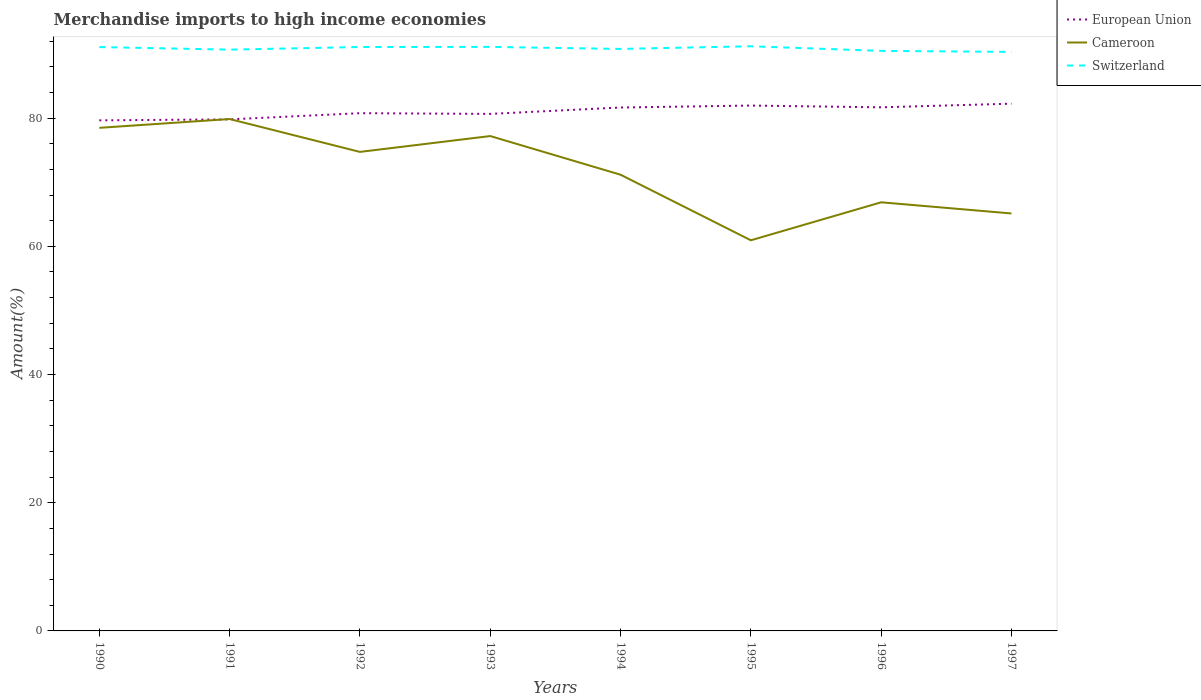How many different coloured lines are there?
Give a very brief answer. 3. Across all years, what is the maximum percentage of amount earned from merchandise imports in Cameroon?
Make the answer very short. 60.94. In which year was the percentage of amount earned from merchandise imports in European Union maximum?
Make the answer very short. 1990. What is the total percentage of amount earned from merchandise imports in Cameroon in the graph?
Provide a succinct answer. 6.05. What is the difference between the highest and the second highest percentage of amount earned from merchandise imports in Switzerland?
Offer a very short reply. 0.88. What is the difference between the highest and the lowest percentage of amount earned from merchandise imports in Cameroon?
Make the answer very short. 4. Is the percentage of amount earned from merchandise imports in Switzerland strictly greater than the percentage of amount earned from merchandise imports in European Union over the years?
Your answer should be very brief. No. How many years are there in the graph?
Keep it short and to the point. 8. What is the difference between two consecutive major ticks on the Y-axis?
Make the answer very short. 20. Where does the legend appear in the graph?
Provide a succinct answer. Top right. What is the title of the graph?
Your response must be concise. Merchandise imports to high income economies. What is the label or title of the Y-axis?
Ensure brevity in your answer.  Amount(%). What is the Amount(%) in European Union in 1990?
Offer a very short reply. 79.65. What is the Amount(%) in Cameroon in 1990?
Provide a short and direct response. 78.49. What is the Amount(%) in Switzerland in 1990?
Give a very brief answer. 91.09. What is the Amount(%) in European Union in 1991?
Your answer should be very brief. 79.8. What is the Amount(%) of Cameroon in 1991?
Make the answer very short. 79.86. What is the Amount(%) in Switzerland in 1991?
Keep it short and to the point. 90.68. What is the Amount(%) of European Union in 1992?
Provide a short and direct response. 80.77. What is the Amount(%) of Cameroon in 1992?
Your answer should be very brief. 74.73. What is the Amount(%) in Switzerland in 1992?
Keep it short and to the point. 91.09. What is the Amount(%) of European Union in 1993?
Give a very brief answer. 80.66. What is the Amount(%) in Cameroon in 1993?
Ensure brevity in your answer.  77.2. What is the Amount(%) in Switzerland in 1993?
Keep it short and to the point. 91.11. What is the Amount(%) of European Union in 1994?
Give a very brief answer. 81.65. What is the Amount(%) of Cameroon in 1994?
Make the answer very short. 71.17. What is the Amount(%) in Switzerland in 1994?
Your answer should be very brief. 90.79. What is the Amount(%) of European Union in 1995?
Offer a terse response. 81.96. What is the Amount(%) of Cameroon in 1995?
Keep it short and to the point. 60.94. What is the Amount(%) of Switzerland in 1995?
Provide a succinct answer. 91.21. What is the Amount(%) in European Union in 1996?
Provide a succinct answer. 81.69. What is the Amount(%) in Cameroon in 1996?
Provide a short and direct response. 66.87. What is the Amount(%) of Switzerland in 1996?
Offer a very short reply. 90.49. What is the Amount(%) in European Union in 1997?
Give a very brief answer. 82.26. What is the Amount(%) of Cameroon in 1997?
Your answer should be very brief. 65.13. What is the Amount(%) in Switzerland in 1997?
Offer a terse response. 90.33. Across all years, what is the maximum Amount(%) in European Union?
Provide a short and direct response. 82.26. Across all years, what is the maximum Amount(%) of Cameroon?
Keep it short and to the point. 79.86. Across all years, what is the maximum Amount(%) of Switzerland?
Give a very brief answer. 91.21. Across all years, what is the minimum Amount(%) in European Union?
Give a very brief answer. 79.65. Across all years, what is the minimum Amount(%) of Cameroon?
Your answer should be compact. 60.94. Across all years, what is the minimum Amount(%) of Switzerland?
Give a very brief answer. 90.33. What is the total Amount(%) in European Union in the graph?
Your answer should be very brief. 648.43. What is the total Amount(%) of Cameroon in the graph?
Your answer should be very brief. 574.38. What is the total Amount(%) of Switzerland in the graph?
Give a very brief answer. 726.79. What is the difference between the Amount(%) of European Union in 1990 and that in 1991?
Your answer should be compact. -0.15. What is the difference between the Amount(%) of Cameroon in 1990 and that in 1991?
Keep it short and to the point. -1.37. What is the difference between the Amount(%) in Switzerland in 1990 and that in 1991?
Offer a very short reply. 0.4. What is the difference between the Amount(%) of European Union in 1990 and that in 1992?
Ensure brevity in your answer.  -1.12. What is the difference between the Amount(%) in Cameroon in 1990 and that in 1992?
Keep it short and to the point. 3.76. What is the difference between the Amount(%) of Switzerland in 1990 and that in 1992?
Offer a terse response. -0.01. What is the difference between the Amount(%) in European Union in 1990 and that in 1993?
Your answer should be very brief. -1. What is the difference between the Amount(%) in Cameroon in 1990 and that in 1993?
Provide a succinct answer. 1.28. What is the difference between the Amount(%) in Switzerland in 1990 and that in 1993?
Your response must be concise. -0.03. What is the difference between the Amount(%) of European Union in 1990 and that in 1994?
Make the answer very short. -2. What is the difference between the Amount(%) of Cameroon in 1990 and that in 1994?
Make the answer very short. 7.31. What is the difference between the Amount(%) in Switzerland in 1990 and that in 1994?
Keep it short and to the point. 0.29. What is the difference between the Amount(%) in European Union in 1990 and that in 1995?
Provide a succinct answer. -2.3. What is the difference between the Amount(%) of Cameroon in 1990 and that in 1995?
Offer a terse response. 17.54. What is the difference between the Amount(%) of Switzerland in 1990 and that in 1995?
Ensure brevity in your answer.  -0.12. What is the difference between the Amount(%) of European Union in 1990 and that in 1996?
Your answer should be compact. -2.03. What is the difference between the Amount(%) in Cameroon in 1990 and that in 1996?
Keep it short and to the point. 11.62. What is the difference between the Amount(%) of Switzerland in 1990 and that in 1996?
Your answer should be very brief. 0.6. What is the difference between the Amount(%) in European Union in 1990 and that in 1997?
Provide a short and direct response. -2.6. What is the difference between the Amount(%) of Cameroon in 1990 and that in 1997?
Your answer should be compact. 13.36. What is the difference between the Amount(%) of Switzerland in 1990 and that in 1997?
Keep it short and to the point. 0.76. What is the difference between the Amount(%) in European Union in 1991 and that in 1992?
Offer a terse response. -0.97. What is the difference between the Amount(%) of Cameroon in 1991 and that in 1992?
Keep it short and to the point. 5.13. What is the difference between the Amount(%) in Switzerland in 1991 and that in 1992?
Keep it short and to the point. -0.41. What is the difference between the Amount(%) in European Union in 1991 and that in 1993?
Keep it short and to the point. -0.86. What is the difference between the Amount(%) in Cameroon in 1991 and that in 1993?
Your answer should be compact. 2.65. What is the difference between the Amount(%) of Switzerland in 1991 and that in 1993?
Provide a succinct answer. -0.43. What is the difference between the Amount(%) of European Union in 1991 and that in 1994?
Your answer should be compact. -1.85. What is the difference between the Amount(%) of Cameroon in 1991 and that in 1994?
Ensure brevity in your answer.  8.69. What is the difference between the Amount(%) in Switzerland in 1991 and that in 1994?
Provide a short and direct response. -0.11. What is the difference between the Amount(%) in European Union in 1991 and that in 1995?
Provide a succinct answer. -2.15. What is the difference between the Amount(%) in Cameroon in 1991 and that in 1995?
Give a very brief answer. 18.92. What is the difference between the Amount(%) of Switzerland in 1991 and that in 1995?
Offer a terse response. -0.52. What is the difference between the Amount(%) in European Union in 1991 and that in 1996?
Your response must be concise. -1.88. What is the difference between the Amount(%) of Cameroon in 1991 and that in 1996?
Provide a succinct answer. 12.99. What is the difference between the Amount(%) in Switzerland in 1991 and that in 1996?
Your response must be concise. 0.2. What is the difference between the Amount(%) of European Union in 1991 and that in 1997?
Your response must be concise. -2.45. What is the difference between the Amount(%) of Cameroon in 1991 and that in 1997?
Ensure brevity in your answer.  14.73. What is the difference between the Amount(%) in Switzerland in 1991 and that in 1997?
Keep it short and to the point. 0.35. What is the difference between the Amount(%) of European Union in 1992 and that in 1993?
Provide a short and direct response. 0.11. What is the difference between the Amount(%) of Cameroon in 1992 and that in 1993?
Your answer should be compact. -2.47. What is the difference between the Amount(%) of Switzerland in 1992 and that in 1993?
Provide a short and direct response. -0.02. What is the difference between the Amount(%) in European Union in 1992 and that in 1994?
Keep it short and to the point. -0.89. What is the difference between the Amount(%) of Cameroon in 1992 and that in 1994?
Offer a terse response. 3.56. What is the difference between the Amount(%) of Switzerland in 1992 and that in 1994?
Make the answer very short. 0.3. What is the difference between the Amount(%) of European Union in 1992 and that in 1995?
Offer a terse response. -1.19. What is the difference between the Amount(%) in Cameroon in 1992 and that in 1995?
Offer a terse response. 13.79. What is the difference between the Amount(%) of Switzerland in 1992 and that in 1995?
Give a very brief answer. -0.12. What is the difference between the Amount(%) of European Union in 1992 and that in 1996?
Offer a terse response. -0.92. What is the difference between the Amount(%) in Cameroon in 1992 and that in 1996?
Provide a succinct answer. 7.86. What is the difference between the Amount(%) in Switzerland in 1992 and that in 1996?
Your response must be concise. 0.61. What is the difference between the Amount(%) of European Union in 1992 and that in 1997?
Make the answer very short. -1.49. What is the difference between the Amount(%) of Cameroon in 1992 and that in 1997?
Make the answer very short. 9.6. What is the difference between the Amount(%) in Switzerland in 1992 and that in 1997?
Your answer should be compact. 0.76. What is the difference between the Amount(%) of European Union in 1993 and that in 1994?
Your response must be concise. -1. What is the difference between the Amount(%) of Cameroon in 1993 and that in 1994?
Ensure brevity in your answer.  6.03. What is the difference between the Amount(%) of Switzerland in 1993 and that in 1994?
Keep it short and to the point. 0.32. What is the difference between the Amount(%) in European Union in 1993 and that in 1995?
Make the answer very short. -1.3. What is the difference between the Amount(%) in Cameroon in 1993 and that in 1995?
Keep it short and to the point. 16.26. What is the difference between the Amount(%) in Switzerland in 1993 and that in 1995?
Your answer should be very brief. -0.1. What is the difference between the Amount(%) of European Union in 1993 and that in 1996?
Keep it short and to the point. -1.03. What is the difference between the Amount(%) of Cameroon in 1993 and that in 1996?
Your answer should be very brief. 10.34. What is the difference between the Amount(%) of Switzerland in 1993 and that in 1996?
Your response must be concise. 0.62. What is the difference between the Amount(%) of European Union in 1993 and that in 1997?
Provide a short and direct response. -1.6. What is the difference between the Amount(%) of Cameroon in 1993 and that in 1997?
Ensure brevity in your answer.  12.08. What is the difference between the Amount(%) in Switzerland in 1993 and that in 1997?
Your answer should be very brief. 0.78. What is the difference between the Amount(%) of European Union in 1994 and that in 1995?
Keep it short and to the point. -0.3. What is the difference between the Amount(%) in Cameroon in 1994 and that in 1995?
Keep it short and to the point. 10.23. What is the difference between the Amount(%) of Switzerland in 1994 and that in 1995?
Your response must be concise. -0.41. What is the difference between the Amount(%) in European Union in 1994 and that in 1996?
Keep it short and to the point. -0.03. What is the difference between the Amount(%) of Cameroon in 1994 and that in 1996?
Ensure brevity in your answer.  4.3. What is the difference between the Amount(%) of Switzerland in 1994 and that in 1996?
Your answer should be very brief. 0.31. What is the difference between the Amount(%) of European Union in 1994 and that in 1997?
Make the answer very short. -0.6. What is the difference between the Amount(%) in Cameroon in 1994 and that in 1997?
Make the answer very short. 6.05. What is the difference between the Amount(%) in Switzerland in 1994 and that in 1997?
Your response must be concise. 0.47. What is the difference between the Amount(%) of European Union in 1995 and that in 1996?
Offer a very short reply. 0.27. What is the difference between the Amount(%) in Cameroon in 1995 and that in 1996?
Give a very brief answer. -5.93. What is the difference between the Amount(%) in Switzerland in 1995 and that in 1996?
Provide a succinct answer. 0.72. What is the difference between the Amount(%) of European Union in 1995 and that in 1997?
Your answer should be compact. -0.3. What is the difference between the Amount(%) in Cameroon in 1995 and that in 1997?
Your response must be concise. -4.18. What is the difference between the Amount(%) of Switzerland in 1995 and that in 1997?
Provide a short and direct response. 0.88. What is the difference between the Amount(%) in European Union in 1996 and that in 1997?
Your answer should be compact. -0.57. What is the difference between the Amount(%) in Cameroon in 1996 and that in 1997?
Your response must be concise. 1.74. What is the difference between the Amount(%) of Switzerland in 1996 and that in 1997?
Your answer should be compact. 0.16. What is the difference between the Amount(%) in European Union in 1990 and the Amount(%) in Cameroon in 1991?
Offer a terse response. -0.2. What is the difference between the Amount(%) of European Union in 1990 and the Amount(%) of Switzerland in 1991?
Give a very brief answer. -11.03. What is the difference between the Amount(%) of Cameroon in 1990 and the Amount(%) of Switzerland in 1991?
Provide a short and direct response. -12.2. What is the difference between the Amount(%) of European Union in 1990 and the Amount(%) of Cameroon in 1992?
Provide a succinct answer. 4.92. What is the difference between the Amount(%) in European Union in 1990 and the Amount(%) in Switzerland in 1992?
Give a very brief answer. -11.44. What is the difference between the Amount(%) in Cameroon in 1990 and the Amount(%) in Switzerland in 1992?
Offer a very short reply. -12.61. What is the difference between the Amount(%) of European Union in 1990 and the Amount(%) of Cameroon in 1993?
Make the answer very short. 2.45. What is the difference between the Amount(%) of European Union in 1990 and the Amount(%) of Switzerland in 1993?
Offer a very short reply. -11.46. What is the difference between the Amount(%) in Cameroon in 1990 and the Amount(%) in Switzerland in 1993?
Give a very brief answer. -12.63. What is the difference between the Amount(%) of European Union in 1990 and the Amount(%) of Cameroon in 1994?
Your response must be concise. 8.48. What is the difference between the Amount(%) of European Union in 1990 and the Amount(%) of Switzerland in 1994?
Your answer should be very brief. -11.14. What is the difference between the Amount(%) in Cameroon in 1990 and the Amount(%) in Switzerland in 1994?
Your response must be concise. -12.31. What is the difference between the Amount(%) of European Union in 1990 and the Amount(%) of Cameroon in 1995?
Give a very brief answer. 18.71. What is the difference between the Amount(%) in European Union in 1990 and the Amount(%) in Switzerland in 1995?
Provide a short and direct response. -11.55. What is the difference between the Amount(%) in Cameroon in 1990 and the Amount(%) in Switzerland in 1995?
Provide a short and direct response. -12.72. What is the difference between the Amount(%) of European Union in 1990 and the Amount(%) of Cameroon in 1996?
Ensure brevity in your answer.  12.79. What is the difference between the Amount(%) of European Union in 1990 and the Amount(%) of Switzerland in 1996?
Your answer should be compact. -10.83. What is the difference between the Amount(%) of Cameroon in 1990 and the Amount(%) of Switzerland in 1996?
Offer a terse response. -12. What is the difference between the Amount(%) in European Union in 1990 and the Amount(%) in Cameroon in 1997?
Provide a short and direct response. 14.53. What is the difference between the Amount(%) in European Union in 1990 and the Amount(%) in Switzerland in 1997?
Your answer should be compact. -10.67. What is the difference between the Amount(%) of Cameroon in 1990 and the Amount(%) of Switzerland in 1997?
Offer a terse response. -11.84. What is the difference between the Amount(%) in European Union in 1991 and the Amount(%) in Cameroon in 1992?
Provide a short and direct response. 5.07. What is the difference between the Amount(%) in European Union in 1991 and the Amount(%) in Switzerland in 1992?
Provide a short and direct response. -11.29. What is the difference between the Amount(%) of Cameroon in 1991 and the Amount(%) of Switzerland in 1992?
Keep it short and to the point. -11.23. What is the difference between the Amount(%) in European Union in 1991 and the Amount(%) in Cameroon in 1993?
Your response must be concise. 2.6. What is the difference between the Amount(%) of European Union in 1991 and the Amount(%) of Switzerland in 1993?
Keep it short and to the point. -11.31. What is the difference between the Amount(%) of Cameroon in 1991 and the Amount(%) of Switzerland in 1993?
Give a very brief answer. -11.25. What is the difference between the Amount(%) of European Union in 1991 and the Amount(%) of Cameroon in 1994?
Your response must be concise. 8.63. What is the difference between the Amount(%) of European Union in 1991 and the Amount(%) of Switzerland in 1994?
Your answer should be very brief. -10.99. What is the difference between the Amount(%) in Cameroon in 1991 and the Amount(%) in Switzerland in 1994?
Provide a short and direct response. -10.94. What is the difference between the Amount(%) in European Union in 1991 and the Amount(%) in Cameroon in 1995?
Your response must be concise. 18.86. What is the difference between the Amount(%) in European Union in 1991 and the Amount(%) in Switzerland in 1995?
Your answer should be very brief. -11.41. What is the difference between the Amount(%) in Cameroon in 1991 and the Amount(%) in Switzerland in 1995?
Give a very brief answer. -11.35. What is the difference between the Amount(%) of European Union in 1991 and the Amount(%) of Cameroon in 1996?
Offer a terse response. 12.94. What is the difference between the Amount(%) of European Union in 1991 and the Amount(%) of Switzerland in 1996?
Your response must be concise. -10.68. What is the difference between the Amount(%) of Cameroon in 1991 and the Amount(%) of Switzerland in 1996?
Give a very brief answer. -10.63. What is the difference between the Amount(%) of European Union in 1991 and the Amount(%) of Cameroon in 1997?
Provide a short and direct response. 14.68. What is the difference between the Amount(%) in European Union in 1991 and the Amount(%) in Switzerland in 1997?
Provide a short and direct response. -10.53. What is the difference between the Amount(%) in Cameroon in 1991 and the Amount(%) in Switzerland in 1997?
Your answer should be very brief. -10.47. What is the difference between the Amount(%) in European Union in 1992 and the Amount(%) in Cameroon in 1993?
Ensure brevity in your answer.  3.57. What is the difference between the Amount(%) in European Union in 1992 and the Amount(%) in Switzerland in 1993?
Make the answer very short. -10.34. What is the difference between the Amount(%) in Cameroon in 1992 and the Amount(%) in Switzerland in 1993?
Make the answer very short. -16.38. What is the difference between the Amount(%) of European Union in 1992 and the Amount(%) of Cameroon in 1994?
Keep it short and to the point. 9.6. What is the difference between the Amount(%) of European Union in 1992 and the Amount(%) of Switzerland in 1994?
Provide a succinct answer. -10.03. What is the difference between the Amount(%) in Cameroon in 1992 and the Amount(%) in Switzerland in 1994?
Offer a very short reply. -16.07. What is the difference between the Amount(%) of European Union in 1992 and the Amount(%) of Cameroon in 1995?
Keep it short and to the point. 19.83. What is the difference between the Amount(%) in European Union in 1992 and the Amount(%) in Switzerland in 1995?
Offer a very short reply. -10.44. What is the difference between the Amount(%) of Cameroon in 1992 and the Amount(%) of Switzerland in 1995?
Provide a short and direct response. -16.48. What is the difference between the Amount(%) of European Union in 1992 and the Amount(%) of Cameroon in 1996?
Keep it short and to the point. 13.9. What is the difference between the Amount(%) in European Union in 1992 and the Amount(%) in Switzerland in 1996?
Provide a succinct answer. -9.72. What is the difference between the Amount(%) of Cameroon in 1992 and the Amount(%) of Switzerland in 1996?
Provide a short and direct response. -15.76. What is the difference between the Amount(%) of European Union in 1992 and the Amount(%) of Cameroon in 1997?
Offer a very short reply. 15.64. What is the difference between the Amount(%) in European Union in 1992 and the Amount(%) in Switzerland in 1997?
Provide a short and direct response. -9.56. What is the difference between the Amount(%) of Cameroon in 1992 and the Amount(%) of Switzerland in 1997?
Your answer should be very brief. -15.6. What is the difference between the Amount(%) in European Union in 1993 and the Amount(%) in Cameroon in 1994?
Make the answer very short. 9.49. What is the difference between the Amount(%) of European Union in 1993 and the Amount(%) of Switzerland in 1994?
Ensure brevity in your answer.  -10.14. What is the difference between the Amount(%) in Cameroon in 1993 and the Amount(%) in Switzerland in 1994?
Provide a short and direct response. -13.59. What is the difference between the Amount(%) of European Union in 1993 and the Amount(%) of Cameroon in 1995?
Offer a very short reply. 19.72. What is the difference between the Amount(%) of European Union in 1993 and the Amount(%) of Switzerland in 1995?
Give a very brief answer. -10.55. What is the difference between the Amount(%) of Cameroon in 1993 and the Amount(%) of Switzerland in 1995?
Your answer should be compact. -14.01. What is the difference between the Amount(%) in European Union in 1993 and the Amount(%) in Cameroon in 1996?
Your response must be concise. 13.79. What is the difference between the Amount(%) in European Union in 1993 and the Amount(%) in Switzerland in 1996?
Provide a short and direct response. -9.83. What is the difference between the Amount(%) in Cameroon in 1993 and the Amount(%) in Switzerland in 1996?
Keep it short and to the point. -13.28. What is the difference between the Amount(%) of European Union in 1993 and the Amount(%) of Cameroon in 1997?
Your answer should be compact. 15.53. What is the difference between the Amount(%) of European Union in 1993 and the Amount(%) of Switzerland in 1997?
Offer a very short reply. -9.67. What is the difference between the Amount(%) in Cameroon in 1993 and the Amount(%) in Switzerland in 1997?
Ensure brevity in your answer.  -13.13. What is the difference between the Amount(%) in European Union in 1994 and the Amount(%) in Cameroon in 1995?
Keep it short and to the point. 20.71. What is the difference between the Amount(%) in European Union in 1994 and the Amount(%) in Switzerland in 1995?
Give a very brief answer. -9.55. What is the difference between the Amount(%) in Cameroon in 1994 and the Amount(%) in Switzerland in 1995?
Your response must be concise. -20.04. What is the difference between the Amount(%) in European Union in 1994 and the Amount(%) in Cameroon in 1996?
Provide a short and direct response. 14.79. What is the difference between the Amount(%) in European Union in 1994 and the Amount(%) in Switzerland in 1996?
Provide a short and direct response. -8.83. What is the difference between the Amount(%) in Cameroon in 1994 and the Amount(%) in Switzerland in 1996?
Your answer should be compact. -19.32. What is the difference between the Amount(%) in European Union in 1994 and the Amount(%) in Cameroon in 1997?
Your answer should be compact. 16.53. What is the difference between the Amount(%) of European Union in 1994 and the Amount(%) of Switzerland in 1997?
Keep it short and to the point. -8.67. What is the difference between the Amount(%) of Cameroon in 1994 and the Amount(%) of Switzerland in 1997?
Your answer should be compact. -19.16. What is the difference between the Amount(%) in European Union in 1995 and the Amount(%) in Cameroon in 1996?
Make the answer very short. 15.09. What is the difference between the Amount(%) of European Union in 1995 and the Amount(%) of Switzerland in 1996?
Give a very brief answer. -8.53. What is the difference between the Amount(%) in Cameroon in 1995 and the Amount(%) in Switzerland in 1996?
Your response must be concise. -29.55. What is the difference between the Amount(%) in European Union in 1995 and the Amount(%) in Cameroon in 1997?
Make the answer very short. 16.83. What is the difference between the Amount(%) of European Union in 1995 and the Amount(%) of Switzerland in 1997?
Keep it short and to the point. -8.37. What is the difference between the Amount(%) of Cameroon in 1995 and the Amount(%) of Switzerland in 1997?
Give a very brief answer. -29.39. What is the difference between the Amount(%) of European Union in 1996 and the Amount(%) of Cameroon in 1997?
Your answer should be very brief. 16.56. What is the difference between the Amount(%) of European Union in 1996 and the Amount(%) of Switzerland in 1997?
Provide a short and direct response. -8.64. What is the difference between the Amount(%) of Cameroon in 1996 and the Amount(%) of Switzerland in 1997?
Provide a short and direct response. -23.46. What is the average Amount(%) in European Union per year?
Ensure brevity in your answer.  81.05. What is the average Amount(%) of Cameroon per year?
Offer a terse response. 71.8. What is the average Amount(%) of Switzerland per year?
Give a very brief answer. 90.85. In the year 1990, what is the difference between the Amount(%) in European Union and Amount(%) in Cameroon?
Your answer should be compact. 1.17. In the year 1990, what is the difference between the Amount(%) of European Union and Amount(%) of Switzerland?
Your answer should be compact. -11.43. In the year 1990, what is the difference between the Amount(%) of Cameroon and Amount(%) of Switzerland?
Make the answer very short. -12.6. In the year 1991, what is the difference between the Amount(%) in European Union and Amount(%) in Cameroon?
Keep it short and to the point. -0.05. In the year 1991, what is the difference between the Amount(%) in European Union and Amount(%) in Switzerland?
Keep it short and to the point. -10.88. In the year 1991, what is the difference between the Amount(%) in Cameroon and Amount(%) in Switzerland?
Your response must be concise. -10.83. In the year 1992, what is the difference between the Amount(%) of European Union and Amount(%) of Cameroon?
Give a very brief answer. 6.04. In the year 1992, what is the difference between the Amount(%) of European Union and Amount(%) of Switzerland?
Provide a short and direct response. -10.32. In the year 1992, what is the difference between the Amount(%) in Cameroon and Amount(%) in Switzerland?
Your answer should be very brief. -16.36. In the year 1993, what is the difference between the Amount(%) of European Union and Amount(%) of Cameroon?
Your answer should be compact. 3.46. In the year 1993, what is the difference between the Amount(%) in European Union and Amount(%) in Switzerland?
Keep it short and to the point. -10.45. In the year 1993, what is the difference between the Amount(%) of Cameroon and Amount(%) of Switzerland?
Your answer should be very brief. -13.91. In the year 1994, what is the difference between the Amount(%) of European Union and Amount(%) of Cameroon?
Ensure brevity in your answer.  10.48. In the year 1994, what is the difference between the Amount(%) of European Union and Amount(%) of Switzerland?
Your answer should be very brief. -9.14. In the year 1994, what is the difference between the Amount(%) in Cameroon and Amount(%) in Switzerland?
Provide a succinct answer. -19.62. In the year 1995, what is the difference between the Amount(%) in European Union and Amount(%) in Cameroon?
Make the answer very short. 21.02. In the year 1995, what is the difference between the Amount(%) of European Union and Amount(%) of Switzerland?
Offer a terse response. -9.25. In the year 1995, what is the difference between the Amount(%) in Cameroon and Amount(%) in Switzerland?
Make the answer very short. -30.27. In the year 1996, what is the difference between the Amount(%) in European Union and Amount(%) in Cameroon?
Provide a short and direct response. 14.82. In the year 1996, what is the difference between the Amount(%) of European Union and Amount(%) of Switzerland?
Keep it short and to the point. -8.8. In the year 1996, what is the difference between the Amount(%) of Cameroon and Amount(%) of Switzerland?
Your response must be concise. -23.62. In the year 1997, what is the difference between the Amount(%) in European Union and Amount(%) in Cameroon?
Keep it short and to the point. 17.13. In the year 1997, what is the difference between the Amount(%) in European Union and Amount(%) in Switzerland?
Your response must be concise. -8.07. In the year 1997, what is the difference between the Amount(%) in Cameroon and Amount(%) in Switzerland?
Your answer should be compact. -25.2. What is the ratio of the Amount(%) of European Union in 1990 to that in 1991?
Your answer should be compact. 1. What is the ratio of the Amount(%) of Cameroon in 1990 to that in 1991?
Your response must be concise. 0.98. What is the ratio of the Amount(%) of Switzerland in 1990 to that in 1991?
Offer a terse response. 1. What is the ratio of the Amount(%) in European Union in 1990 to that in 1992?
Provide a short and direct response. 0.99. What is the ratio of the Amount(%) in Cameroon in 1990 to that in 1992?
Give a very brief answer. 1.05. What is the ratio of the Amount(%) of Switzerland in 1990 to that in 1992?
Make the answer very short. 1. What is the ratio of the Amount(%) in European Union in 1990 to that in 1993?
Provide a succinct answer. 0.99. What is the ratio of the Amount(%) in Cameroon in 1990 to that in 1993?
Keep it short and to the point. 1.02. What is the ratio of the Amount(%) in European Union in 1990 to that in 1994?
Keep it short and to the point. 0.98. What is the ratio of the Amount(%) in Cameroon in 1990 to that in 1994?
Make the answer very short. 1.1. What is the ratio of the Amount(%) of Switzerland in 1990 to that in 1994?
Offer a terse response. 1. What is the ratio of the Amount(%) in European Union in 1990 to that in 1995?
Your answer should be very brief. 0.97. What is the ratio of the Amount(%) in Cameroon in 1990 to that in 1995?
Your answer should be compact. 1.29. What is the ratio of the Amount(%) in European Union in 1990 to that in 1996?
Offer a very short reply. 0.98. What is the ratio of the Amount(%) in Cameroon in 1990 to that in 1996?
Your answer should be compact. 1.17. What is the ratio of the Amount(%) in Switzerland in 1990 to that in 1996?
Offer a very short reply. 1.01. What is the ratio of the Amount(%) of European Union in 1990 to that in 1997?
Give a very brief answer. 0.97. What is the ratio of the Amount(%) in Cameroon in 1990 to that in 1997?
Offer a terse response. 1.21. What is the ratio of the Amount(%) of Switzerland in 1990 to that in 1997?
Ensure brevity in your answer.  1.01. What is the ratio of the Amount(%) in Cameroon in 1991 to that in 1992?
Provide a succinct answer. 1.07. What is the ratio of the Amount(%) of European Union in 1991 to that in 1993?
Offer a very short reply. 0.99. What is the ratio of the Amount(%) of Cameroon in 1991 to that in 1993?
Provide a succinct answer. 1.03. What is the ratio of the Amount(%) in Switzerland in 1991 to that in 1993?
Give a very brief answer. 1. What is the ratio of the Amount(%) in European Union in 1991 to that in 1994?
Your answer should be very brief. 0.98. What is the ratio of the Amount(%) of Cameroon in 1991 to that in 1994?
Offer a terse response. 1.12. What is the ratio of the Amount(%) in European Union in 1991 to that in 1995?
Provide a succinct answer. 0.97. What is the ratio of the Amount(%) of Cameroon in 1991 to that in 1995?
Ensure brevity in your answer.  1.31. What is the ratio of the Amount(%) in Cameroon in 1991 to that in 1996?
Keep it short and to the point. 1.19. What is the ratio of the Amount(%) in Switzerland in 1991 to that in 1996?
Keep it short and to the point. 1. What is the ratio of the Amount(%) in European Union in 1991 to that in 1997?
Your response must be concise. 0.97. What is the ratio of the Amount(%) in Cameroon in 1991 to that in 1997?
Give a very brief answer. 1.23. What is the ratio of the Amount(%) of European Union in 1992 to that in 1993?
Offer a terse response. 1. What is the ratio of the Amount(%) of European Union in 1992 to that in 1994?
Give a very brief answer. 0.99. What is the ratio of the Amount(%) in Switzerland in 1992 to that in 1994?
Make the answer very short. 1. What is the ratio of the Amount(%) of European Union in 1992 to that in 1995?
Provide a succinct answer. 0.99. What is the ratio of the Amount(%) in Cameroon in 1992 to that in 1995?
Keep it short and to the point. 1.23. What is the ratio of the Amount(%) in European Union in 1992 to that in 1996?
Your answer should be compact. 0.99. What is the ratio of the Amount(%) of Cameroon in 1992 to that in 1996?
Keep it short and to the point. 1.12. What is the ratio of the Amount(%) in Switzerland in 1992 to that in 1996?
Your response must be concise. 1.01. What is the ratio of the Amount(%) in European Union in 1992 to that in 1997?
Provide a short and direct response. 0.98. What is the ratio of the Amount(%) of Cameroon in 1992 to that in 1997?
Make the answer very short. 1.15. What is the ratio of the Amount(%) of Switzerland in 1992 to that in 1997?
Offer a terse response. 1.01. What is the ratio of the Amount(%) of Cameroon in 1993 to that in 1994?
Provide a short and direct response. 1.08. What is the ratio of the Amount(%) of Switzerland in 1993 to that in 1994?
Keep it short and to the point. 1. What is the ratio of the Amount(%) in European Union in 1993 to that in 1995?
Your answer should be very brief. 0.98. What is the ratio of the Amount(%) in Cameroon in 1993 to that in 1995?
Your response must be concise. 1.27. What is the ratio of the Amount(%) in European Union in 1993 to that in 1996?
Your answer should be very brief. 0.99. What is the ratio of the Amount(%) in Cameroon in 1993 to that in 1996?
Offer a terse response. 1.15. What is the ratio of the Amount(%) of European Union in 1993 to that in 1997?
Your response must be concise. 0.98. What is the ratio of the Amount(%) in Cameroon in 1993 to that in 1997?
Give a very brief answer. 1.19. What is the ratio of the Amount(%) of Switzerland in 1993 to that in 1997?
Give a very brief answer. 1.01. What is the ratio of the Amount(%) of European Union in 1994 to that in 1995?
Provide a short and direct response. 1. What is the ratio of the Amount(%) of Cameroon in 1994 to that in 1995?
Offer a very short reply. 1.17. What is the ratio of the Amount(%) in Switzerland in 1994 to that in 1995?
Offer a terse response. 1. What is the ratio of the Amount(%) of European Union in 1994 to that in 1996?
Provide a short and direct response. 1. What is the ratio of the Amount(%) of Cameroon in 1994 to that in 1996?
Make the answer very short. 1.06. What is the ratio of the Amount(%) in Switzerland in 1994 to that in 1996?
Your answer should be compact. 1. What is the ratio of the Amount(%) in European Union in 1994 to that in 1997?
Your answer should be very brief. 0.99. What is the ratio of the Amount(%) in Cameroon in 1994 to that in 1997?
Keep it short and to the point. 1.09. What is the ratio of the Amount(%) in Switzerland in 1994 to that in 1997?
Offer a terse response. 1.01. What is the ratio of the Amount(%) in European Union in 1995 to that in 1996?
Ensure brevity in your answer.  1. What is the ratio of the Amount(%) in Cameroon in 1995 to that in 1996?
Ensure brevity in your answer.  0.91. What is the ratio of the Amount(%) of European Union in 1995 to that in 1997?
Provide a short and direct response. 1. What is the ratio of the Amount(%) in Cameroon in 1995 to that in 1997?
Provide a short and direct response. 0.94. What is the ratio of the Amount(%) in Switzerland in 1995 to that in 1997?
Provide a short and direct response. 1.01. What is the ratio of the Amount(%) of Cameroon in 1996 to that in 1997?
Provide a succinct answer. 1.03. What is the ratio of the Amount(%) of Switzerland in 1996 to that in 1997?
Your answer should be very brief. 1. What is the difference between the highest and the second highest Amount(%) in European Union?
Your response must be concise. 0.3. What is the difference between the highest and the second highest Amount(%) in Cameroon?
Your answer should be compact. 1.37. What is the difference between the highest and the second highest Amount(%) in Switzerland?
Keep it short and to the point. 0.1. What is the difference between the highest and the lowest Amount(%) in European Union?
Offer a very short reply. 2.6. What is the difference between the highest and the lowest Amount(%) of Cameroon?
Ensure brevity in your answer.  18.92. What is the difference between the highest and the lowest Amount(%) in Switzerland?
Provide a succinct answer. 0.88. 